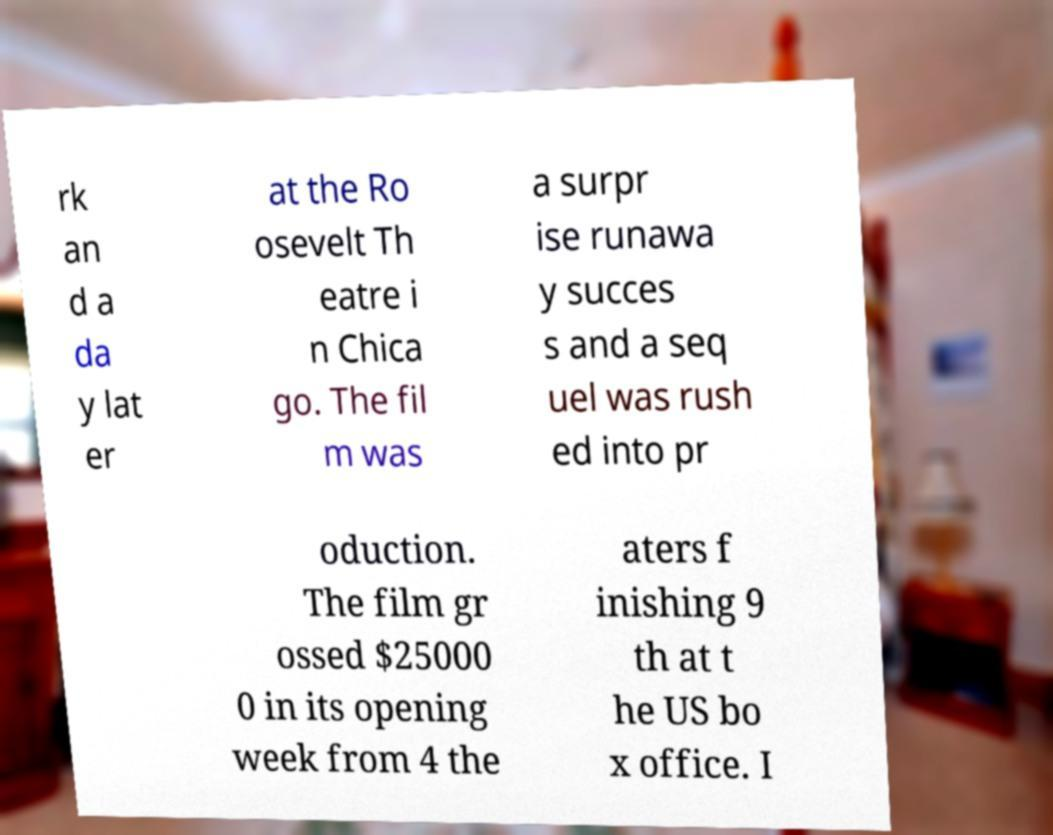Could you assist in decoding the text presented in this image and type it out clearly? rk an d a da y lat er at the Ro osevelt Th eatre i n Chica go. The fil m was a surpr ise runawa y succes s and a seq uel was rush ed into pr oduction. The film gr ossed $25000 0 in its opening week from 4 the aters f inishing 9 th at t he US bo x office. I 